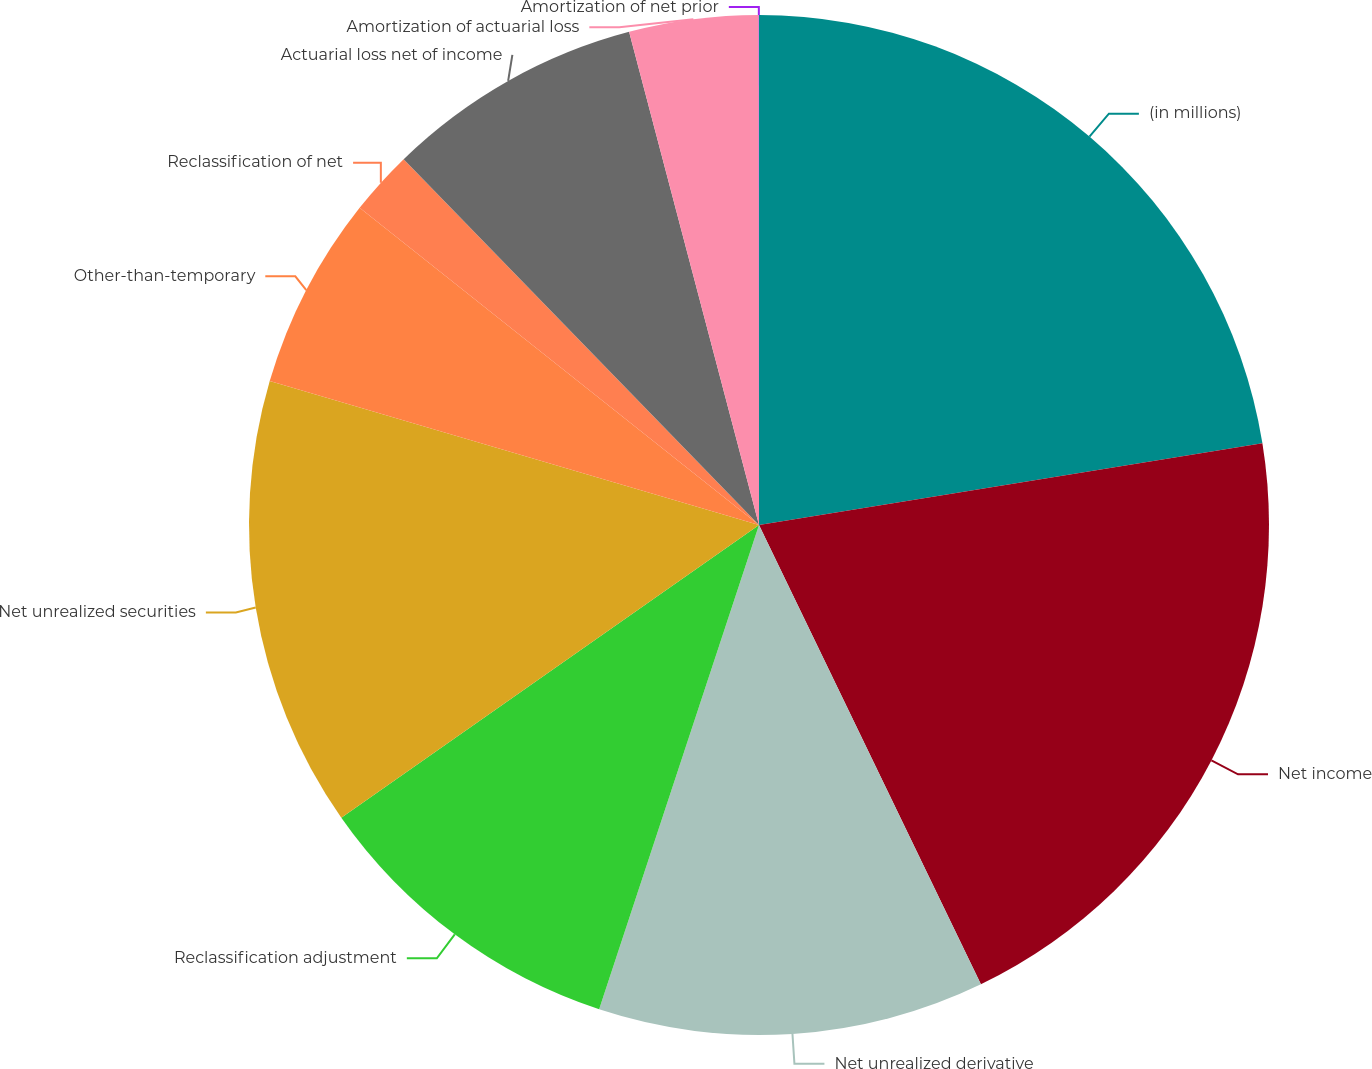Convert chart. <chart><loc_0><loc_0><loc_500><loc_500><pie_chart><fcel>(in millions)<fcel>Net income<fcel>Net unrealized derivative<fcel>Reclassification adjustment<fcel>Net unrealized securities<fcel>Other-than-temporary<fcel>Reclassification of net<fcel>Actuarial loss net of income<fcel>Amortization of actuarial loss<fcel>Amortization of net prior<nl><fcel>22.44%<fcel>20.4%<fcel>12.24%<fcel>10.2%<fcel>14.28%<fcel>6.13%<fcel>2.05%<fcel>8.17%<fcel>4.09%<fcel>0.01%<nl></chart> 